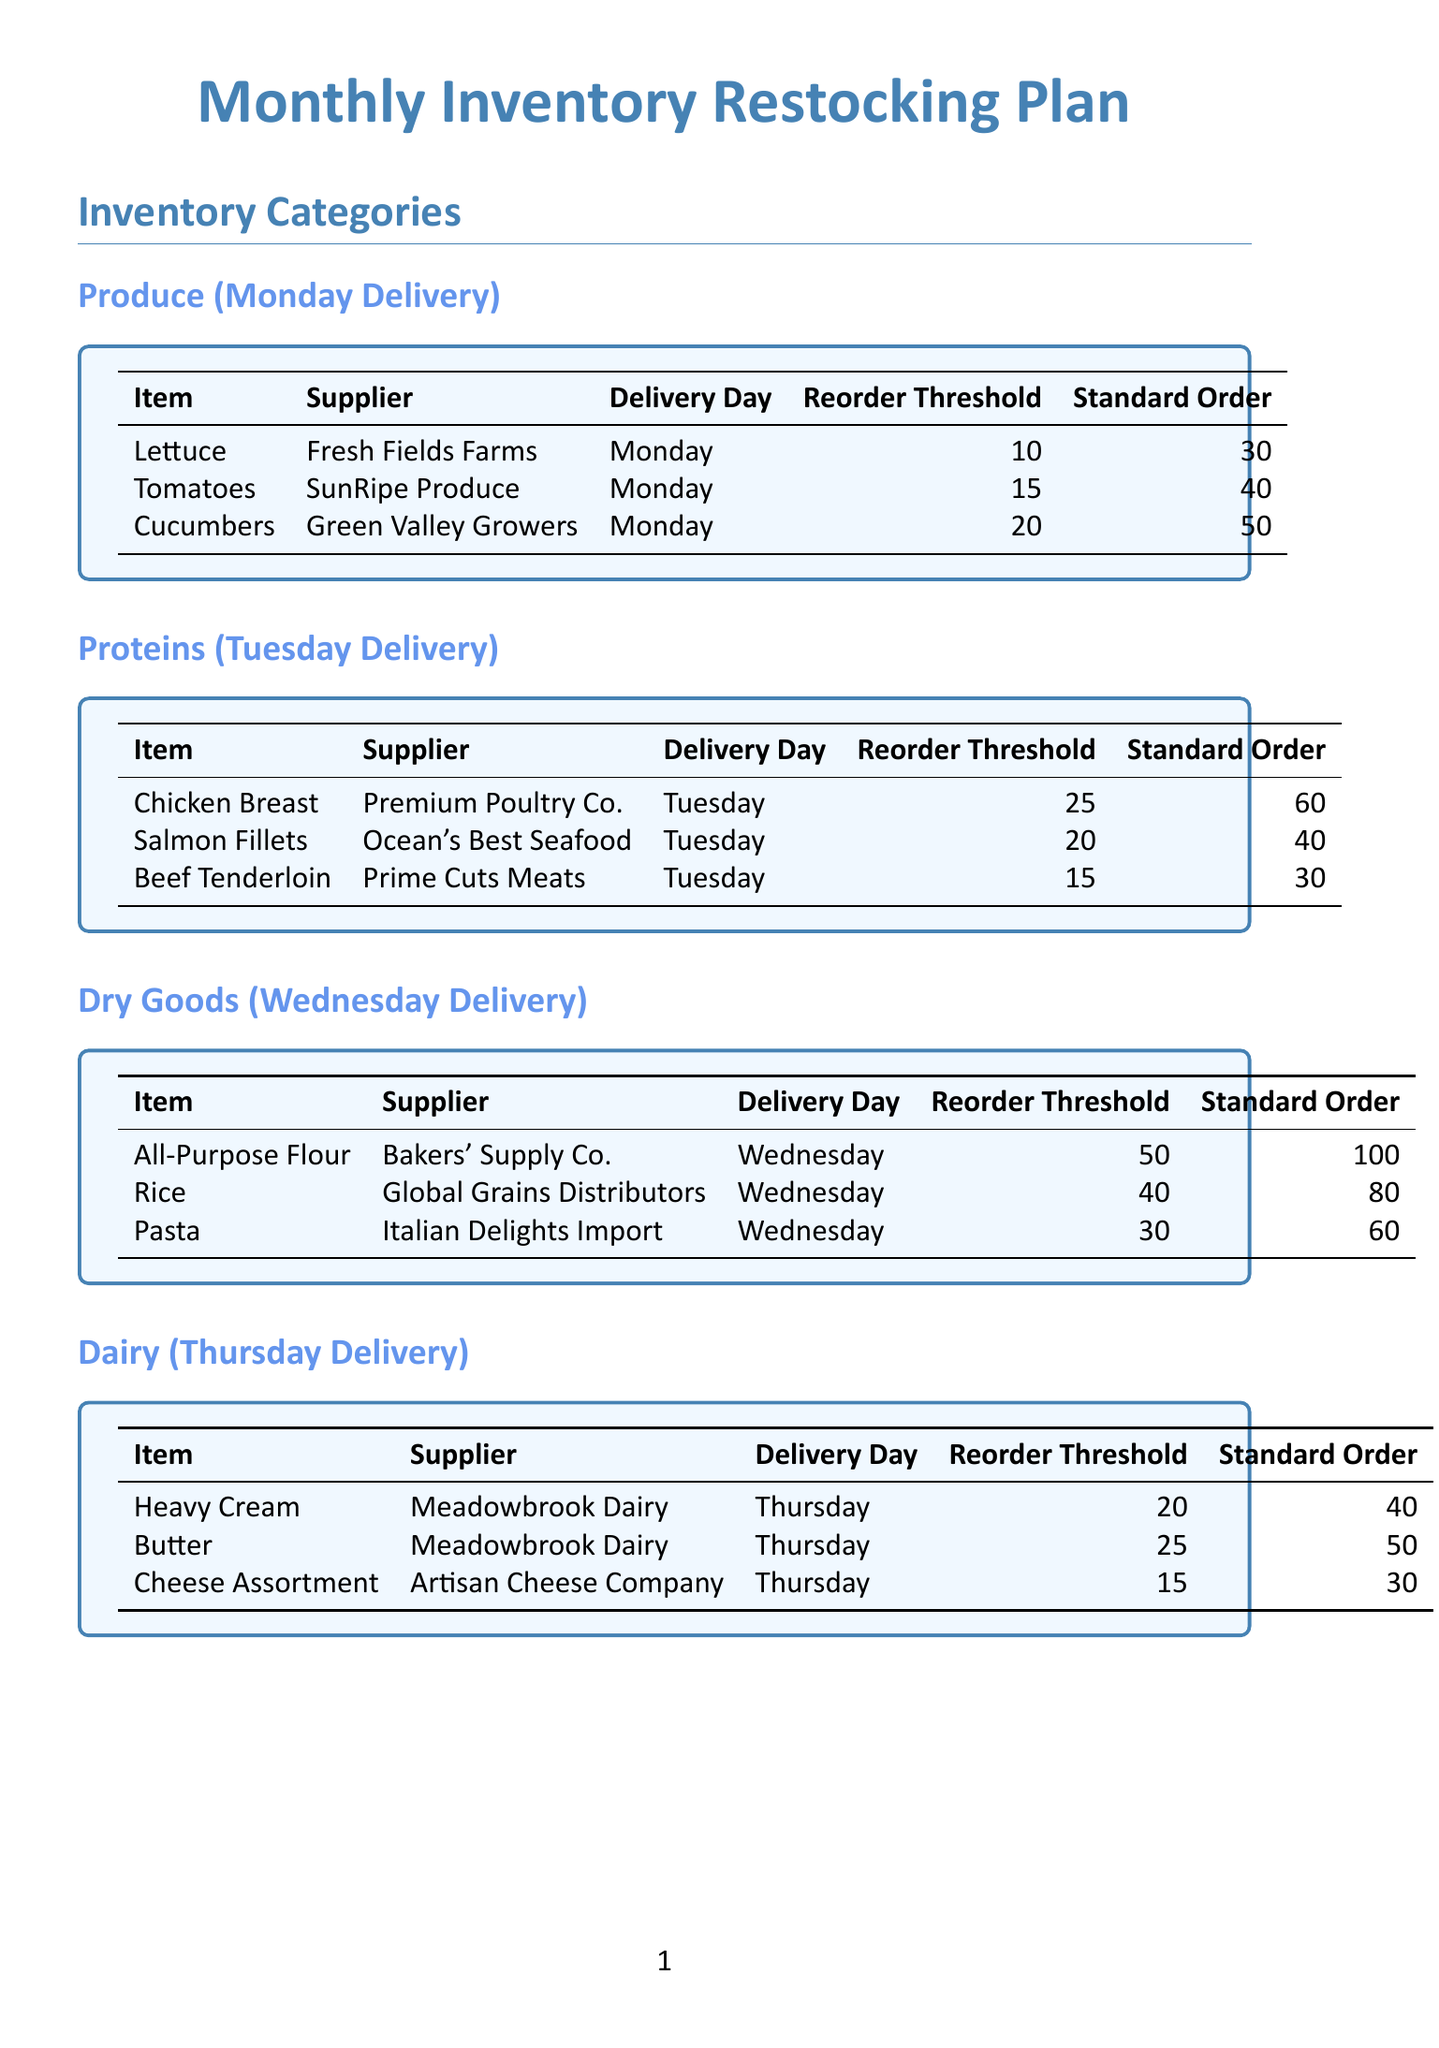What is the delivery day for Tomatoes? The delivery day for Tomatoes is specified in the document under the Produce category.
Answer: Monday What is the reorder threshold for Salmon Fillets? The reorder threshold for Salmon Fillets is mentioned in the Proteins section of the document.
Answer: 20 How many units of All-Purpose Flour are ordered? The standard order quantity for All-Purpose Flour is listed in the Dry Goods table.
Answer: 100 On which day is the inventory check scheduled mid-week? The inventory check day is mentioned in the Inventory Check Schedule section.
Answer: Wednesday Which supplier provides Cheese Assortment? The supplier for Cheese Assortment is specified in the Dairy section.
Answer: Artisan Cheese Company How many items must be reordered for Sparkling Water? The reorder threshold for Sparkling Water is indicated in the Beverages table.
Answer: 100 What type of items does Allergen-Free Foods Inc. supply? The type of items supplied by Allergen-Free Foods Inc. is mentioned in the Special Considerations section.
Answer: Special Dietary Items What is the contact number for Quick Stock Distributors? The contact number is detailed under the Emergency Suppliers section.
Answer: +1 (555) 123-4567 What task is scheduled for Sunday? The specific task for Sunday is outlined in the Inventory Check Schedule section.
Answer: Complete full inventory count and create order list for the week 